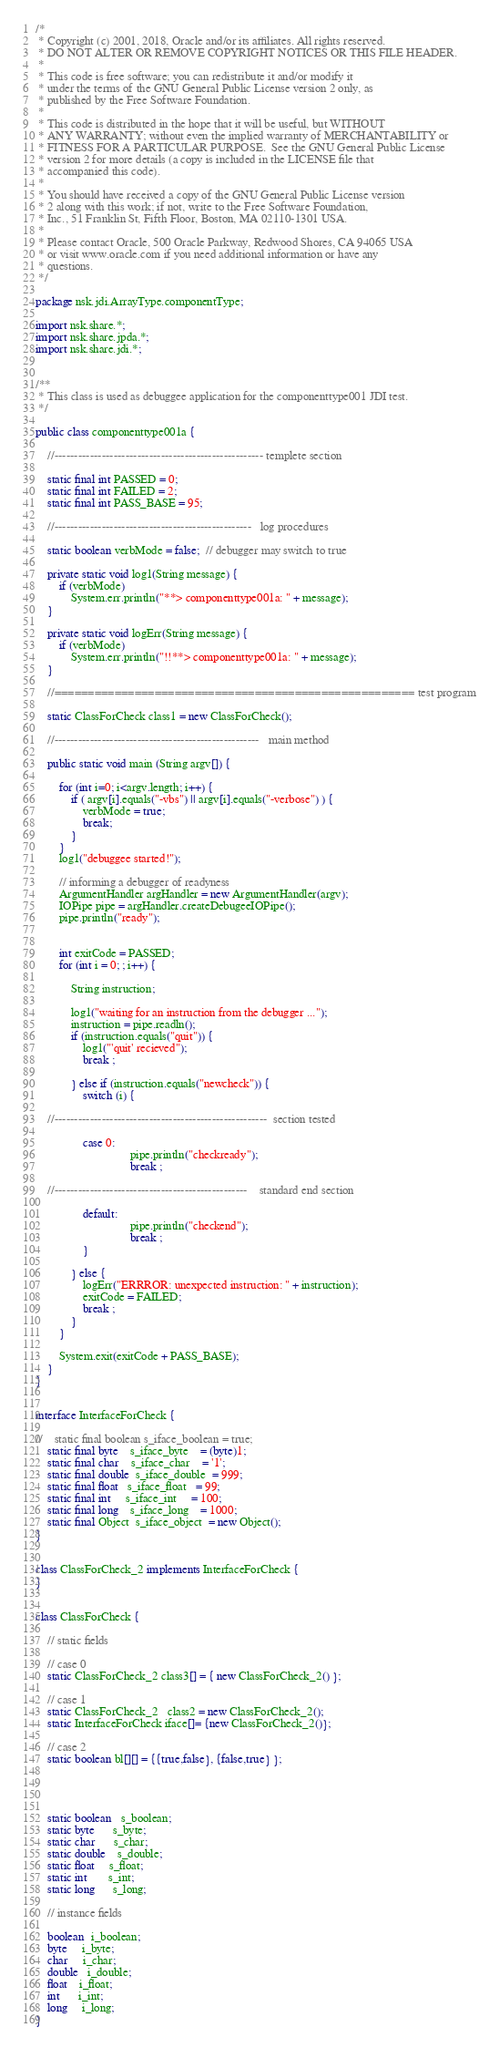<code> <loc_0><loc_0><loc_500><loc_500><_Java_>/*
 * Copyright (c) 2001, 2018, Oracle and/or its affiliates. All rights reserved.
 * DO NOT ALTER OR REMOVE COPYRIGHT NOTICES OR THIS FILE HEADER.
 *
 * This code is free software; you can redistribute it and/or modify it
 * under the terms of the GNU General Public License version 2 only, as
 * published by the Free Software Foundation.
 *
 * This code is distributed in the hope that it will be useful, but WITHOUT
 * ANY WARRANTY; without even the implied warranty of MERCHANTABILITY or
 * FITNESS FOR A PARTICULAR PURPOSE.  See the GNU General Public License
 * version 2 for more details (a copy is included in the LICENSE file that
 * accompanied this code).
 *
 * You should have received a copy of the GNU General Public License version
 * 2 along with this work; if not, write to the Free Software Foundation,
 * Inc., 51 Franklin St, Fifth Floor, Boston, MA 02110-1301 USA.
 *
 * Please contact Oracle, 500 Oracle Parkway, Redwood Shores, CA 94065 USA
 * or visit www.oracle.com if you need additional information or have any
 * questions.
 */

package nsk.jdi.ArrayType.componentType;

import nsk.share.*;
import nsk.share.jpda.*;
import nsk.share.jdi.*;


/**
 * This class is used as debuggee application for the componenttype001 JDI test.
 */

public class componenttype001a {

    //----------------------------------------------------- templete section

    static final int PASSED = 0;
    static final int FAILED = 2;
    static final int PASS_BASE = 95;

    //--------------------------------------------------   log procedures

    static boolean verbMode = false;  // debugger may switch to true

    private static void log1(String message) {
        if (verbMode)
            System.err.println("**> componenttype001a: " + message);
    }

    private static void logErr(String message) {
        if (verbMode)
            System.err.println("!!**> componenttype001a: " + message);
    }

    //====================================================== test program

    static ClassForCheck class1 = new ClassForCheck();

    //----------------------------------------------------   main method

    public static void main (String argv[]) {

        for (int i=0; i<argv.length; i++) {
            if ( argv[i].equals("-vbs") || argv[i].equals("-verbose") ) {
                verbMode = true;
                break;
            }
        }
        log1("debuggee started!");

        // informing a debugger of readyness
        ArgumentHandler argHandler = new ArgumentHandler(argv);
        IOPipe pipe = argHandler.createDebugeeIOPipe();
        pipe.println("ready");


        int exitCode = PASSED;
        for (int i = 0; ; i++) {

            String instruction;

            log1("waiting for an instruction from the debugger ...");
            instruction = pipe.readln();
            if (instruction.equals("quit")) {
                log1("'quit' recieved");
                break ;

            } else if (instruction.equals("newcheck")) {
                switch (i) {

    //------------------------------------------------------  section tested

                case 0:
                                pipe.println("checkready");
                                break ;

    //-------------------------------------------------    standard end section

                default:
                                pipe.println("checkend");
                                break ;
                }

            } else {
                logErr("ERRROR: unexpected instruction: " + instruction);
                exitCode = FAILED;
                break ;
            }
        }

        System.exit(exitCode + PASS_BASE);
    }
}


interface InterfaceForCheck {

//    static final boolean s_iface_boolean = true;
    static final byte    s_iface_byte    = (byte)1;
    static final char    s_iface_char    = '1';
    static final double  s_iface_double  = 999;
    static final float   s_iface_float   = 99;
    static final int     s_iface_int     = 100;
    static final long    s_iface_long    = 1000;
    static final Object  s_iface_object  = new Object();
}


class ClassForCheck_2 implements InterfaceForCheck {
}


class ClassForCheck {

    // static fields

    // case 0
    static ClassForCheck_2 class3[] = { new ClassForCheck_2() };

    // case 1
    static ClassForCheck_2   class2 = new ClassForCheck_2();
    static InterfaceForCheck iface[]= {new ClassForCheck_2()};

    // case 2
    static boolean bl[][] = {{true,false}, {false,true} };




    static boolean   s_boolean;
    static byte      s_byte;
    static char      s_char;
    static double    s_double;
    static float     s_float;
    static int       s_int;
    static long      s_long;

    // instance fields

    boolean  i_boolean;
    byte     i_byte;
    char     i_char;
    double   i_double;
    float    i_float;
    int      i_int;
    long     i_long;
}
</code> 